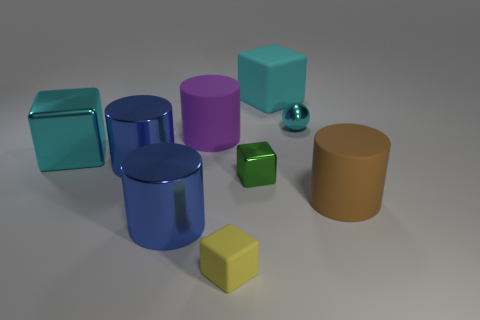Add 1 blue metal objects. How many objects exist? 10 Subtract all cylinders. How many objects are left? 5 Subtract 1 green cubes. How many objects are left? 8 Subtract all big cyan rubber things. Subtract all small green objects. How many objects are left? 7 Add 3 small things. How many small things are left? 6 Add 7 big blue things. How many big blue things exist? 9 